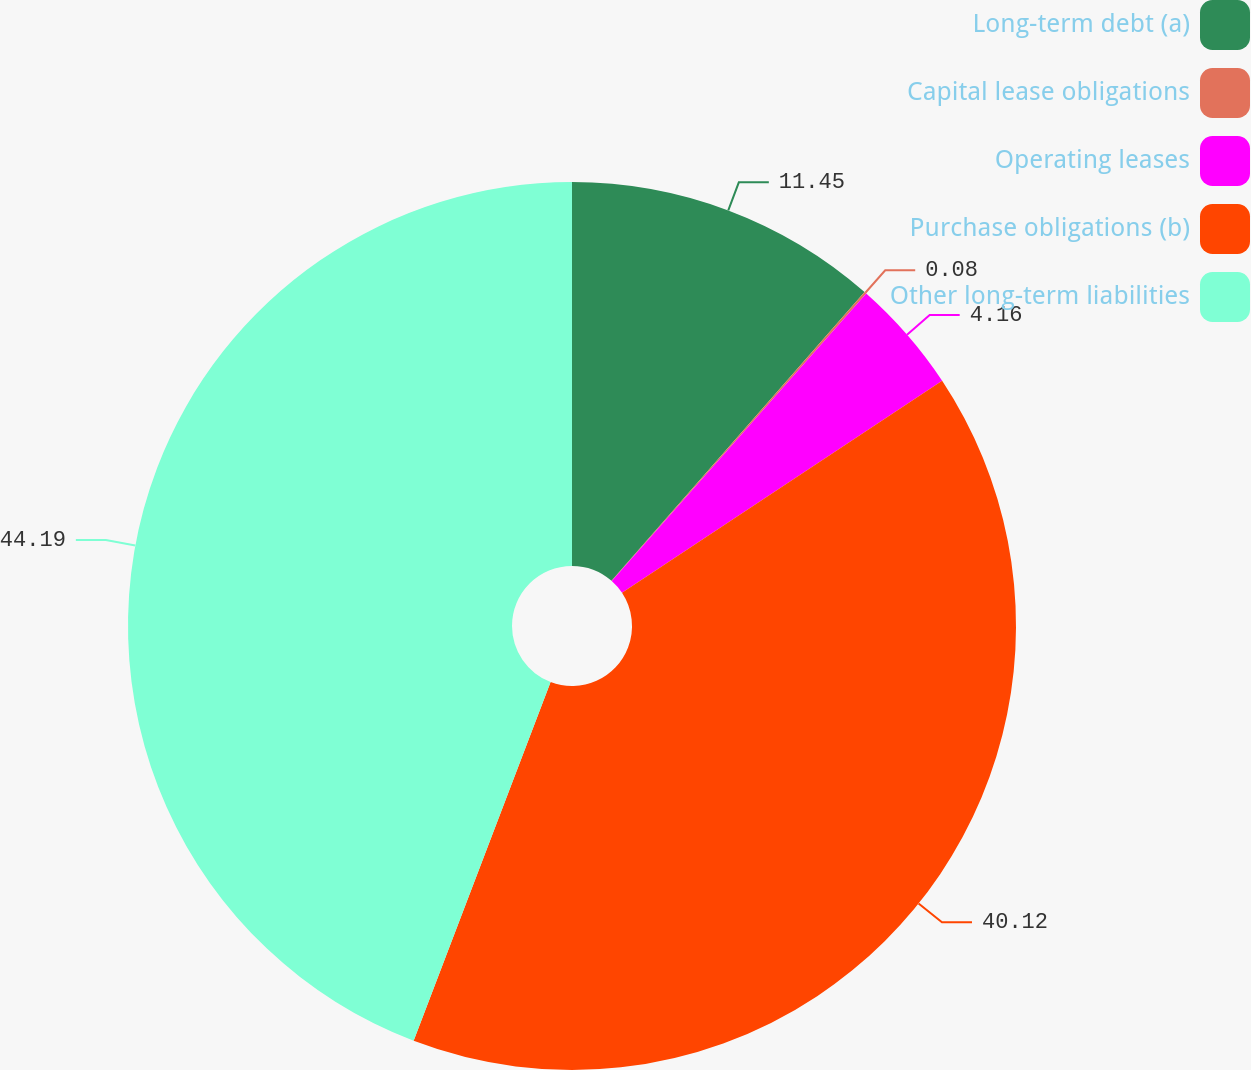<chart> <loc_0><loc_0><loc_500><loc_500><pie_chart><fcel>Long-term debt (a)<fcel>Capital lease obligations<fcel>Operating leases<fcel>Purchase obligations (b)<fcel>Other long-term liabilities<nl><fcel>11.45%<fcel>0.08%<fcel>4.16%<fcel>40.12%<fcel>44.2%<nl></chart> 